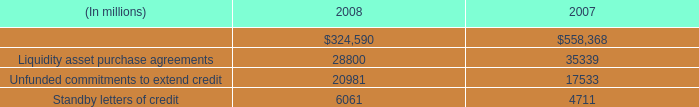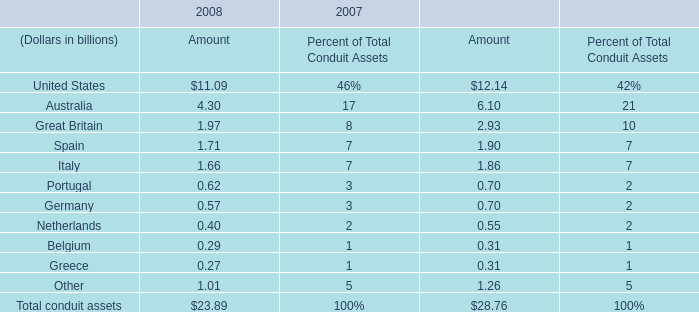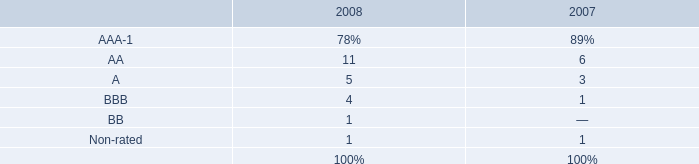between 2007 and 2008 , what percent did the value of standby letters of credit increase? 
Computations: ((6061 - 4711) / 4711)
Answer: 0.28656. 